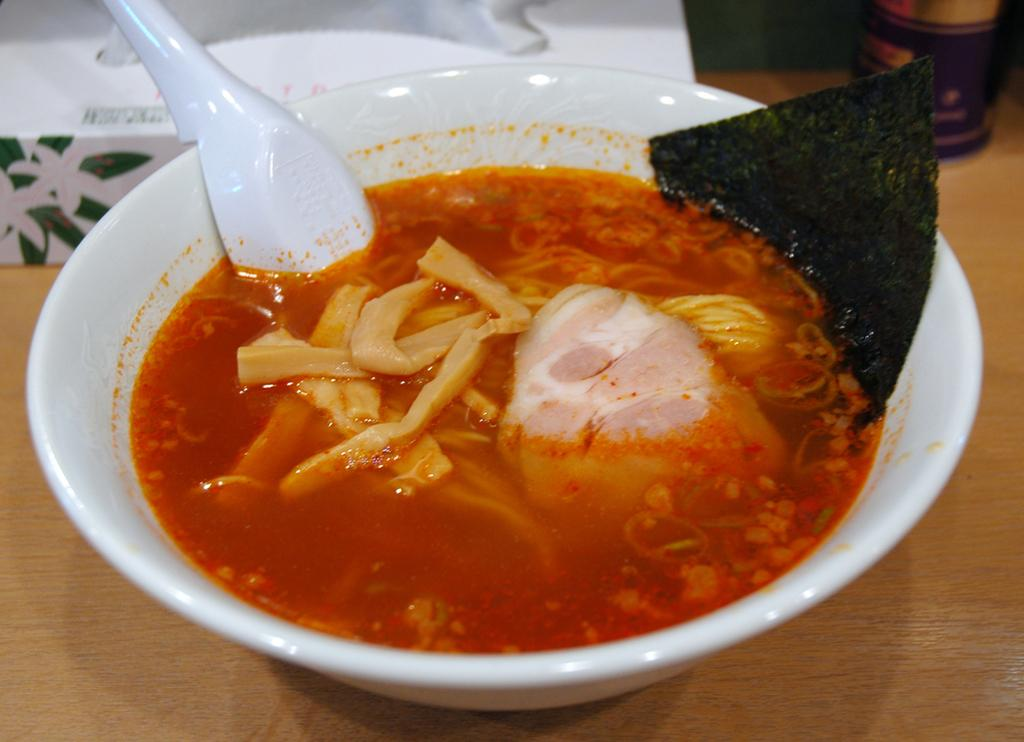What is in the bowl that is visible in the image? There is a bowl with food in the image. What utensil is present in the bowl? There is a spoon in the bowl. What type of bubble can be seen floating near the bowl in the image? There is no bubble present in the image; it only features a bowl with food and a spoon. 